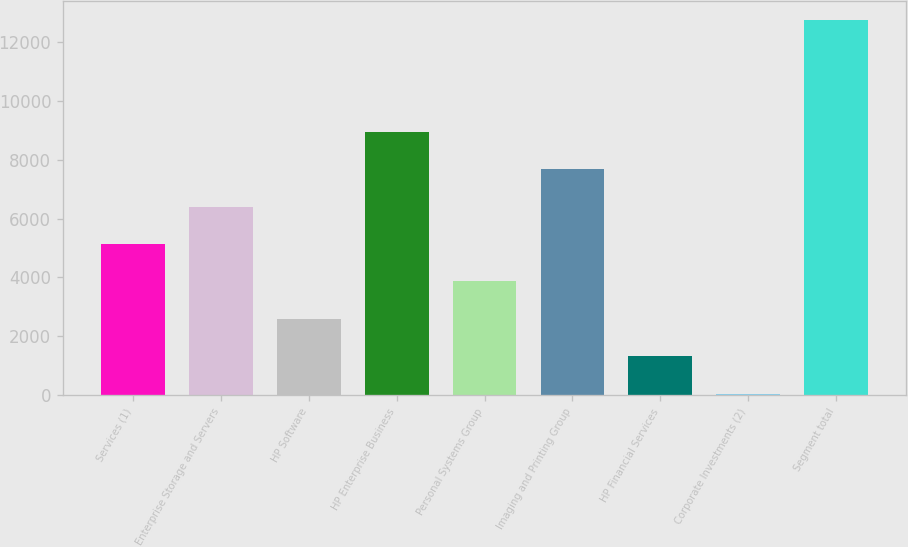Convert chart to OTSL. <chart><loc_0><loc_0><loc_500><loc_500><bar_chart><fcel>Services (1)<fcel>Enterprise Storage and Servers<fcel>HP Software<fcel>HP Enterprise Business<fcel>Personal Systems Group<fcel>Imaging and Printing Group<fcel>HP Financial Services<fcel>Corporate Investments (2)<fcel>Segment total<nl><fcel>5137<fcel>6409<fcel>2593<fcel>8953<fcel>3865<fcel>7681<fcel>1321<fcel>49<fcel>12769<nl></chart> 